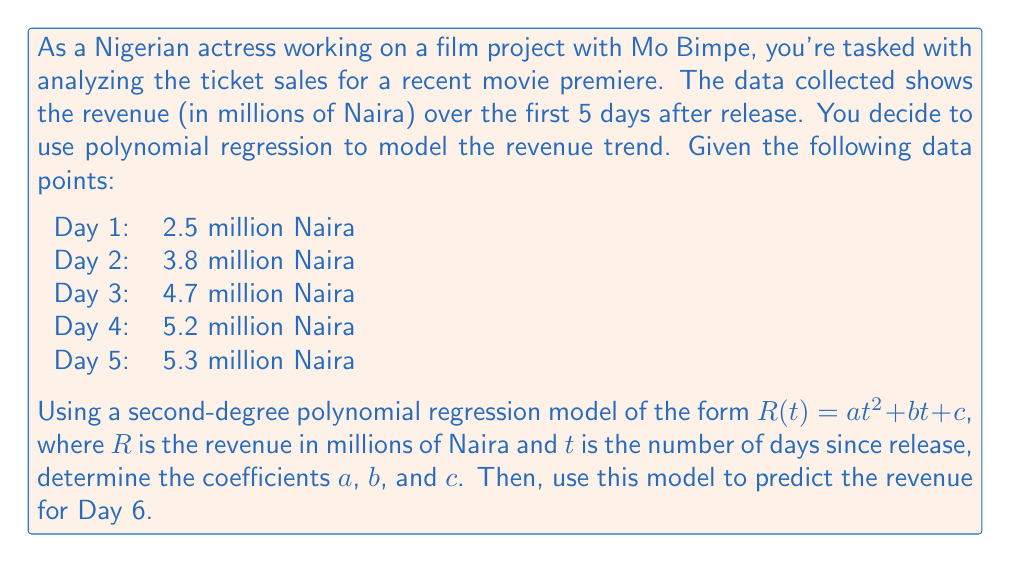Can you answer this question? To solve this problem, we'll follow these steps:

1) First, we need to set up the system of equations using the given data points:

   $$2.5 = a(1)^2 + b(1) + c$$
   $$3.8 = a(2)^2 + b(2) + c$$
   $$4.7 = a(3)^2 + b(3) + c$$
   $$5.2 = a(4)^2 + b(4) + c$$
   $$5.3 = a(5)^2 + b(5) + c$$

2) We can solve this system using the method of least squares. However, for simplicity, we'll use a matrix approach. Let's set up the matrices:

   $$\begin{bmatrix} 
   1 & 1 & 1 \\
   4 & 2 & 1 \\
   9 & 3 & 1 \\
   16 & 4 & 1 \\
   25 & 5 & 1
   \end{bmatrix}
   \begin{bmatrix}
   a \\
   b \\
   c
   \end{bmatrix} =
   \begin{bmatrix}
   2.5 \\
   3.8 \\
   4.7 \\
   5.2 \\
   5.3
   \end{bmatrix}$$

3) Solving this system (using a calculator or computer algebra system) gives us:

   $$a \approx -0.185$$
   $$b \approx 1.795$$
   $$c \approx 0.89$$

4) Therefore, our polynomial regression model is:

   $$R(t) = -0.185t^2 + 1.795t + 0.89$$

5) To predict the revenue for Day 6, we simply plug in $t = 6$ into our model:

   $$R(6) = -0.185(6)^2 + 1.795(6) + 0.89$$
   $$= -0.185(36) + 10.77 + 0.89$$
   $$= -6.66 + 10.77 + 0.89$$
   $$= 5.00$$

Thus, the predicted revenue for Day 6 is approximately 5.00 million Naira.
Answer: The coefficients of the polynomial regression model are:
$a \approx -0.185$, $b \approx 1.795$, $c \approx 0.89$

The predicted revenue for Day 6 is approximately 5.00 million Naira. 